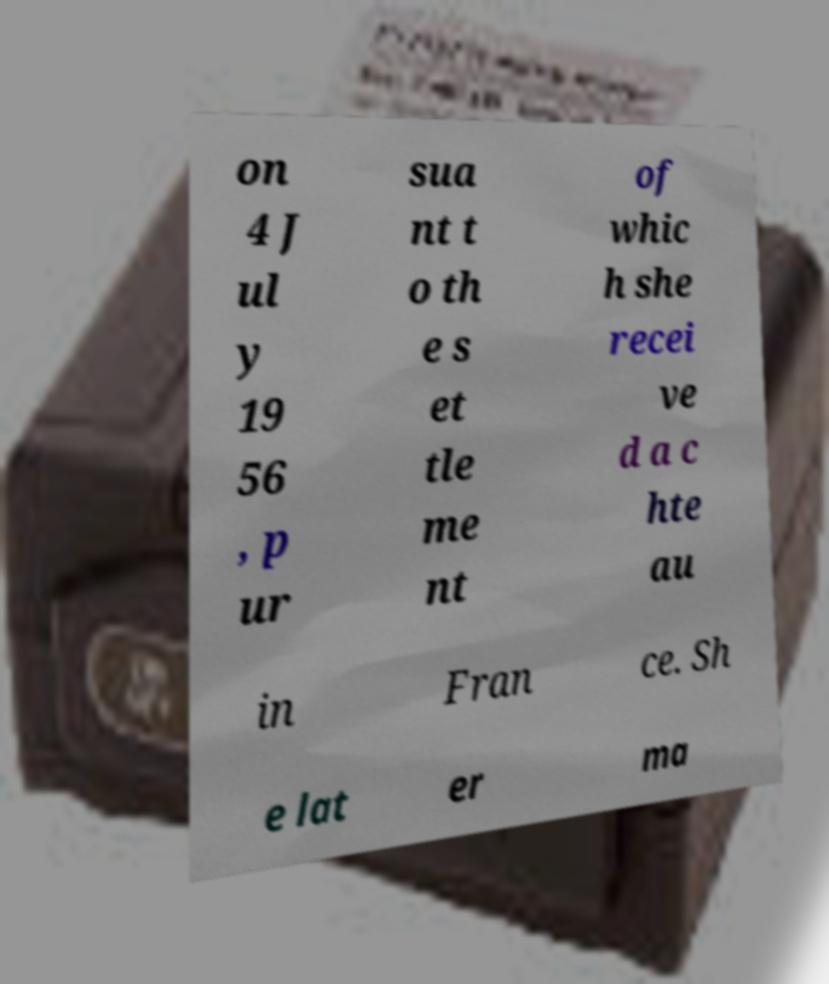Please read and relay the text visible in this image. What does it say? on 4 J ul y 19 56 , p ur sua nt t o th e s et tle me nt of whic h she recei ve d a c hte au in Fran ce. Sh e lat er ma 